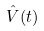<formula> <loc_0><loc_0><loc_500><loc_500>\hat { V } ( t )</formula> 